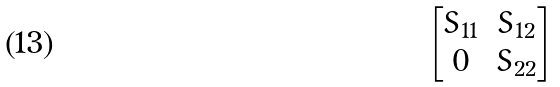Convert formula to latex. <formula><loc_0><loc_0><loc_500><loc_500>\begin{bmatrix} S _ { 1 1 } & S _ { 1 2 } \\ 0 & S _ { 2 2 } \end{bmatrix}</formula> 